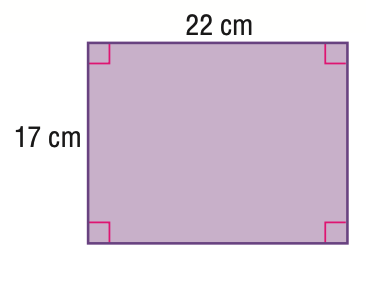Question: Find the area of the figure. Round to the nearest tenth.
Choices:
A. 78
B. 364
C. 374
D. 484
Answer with the letter. Answer: C 